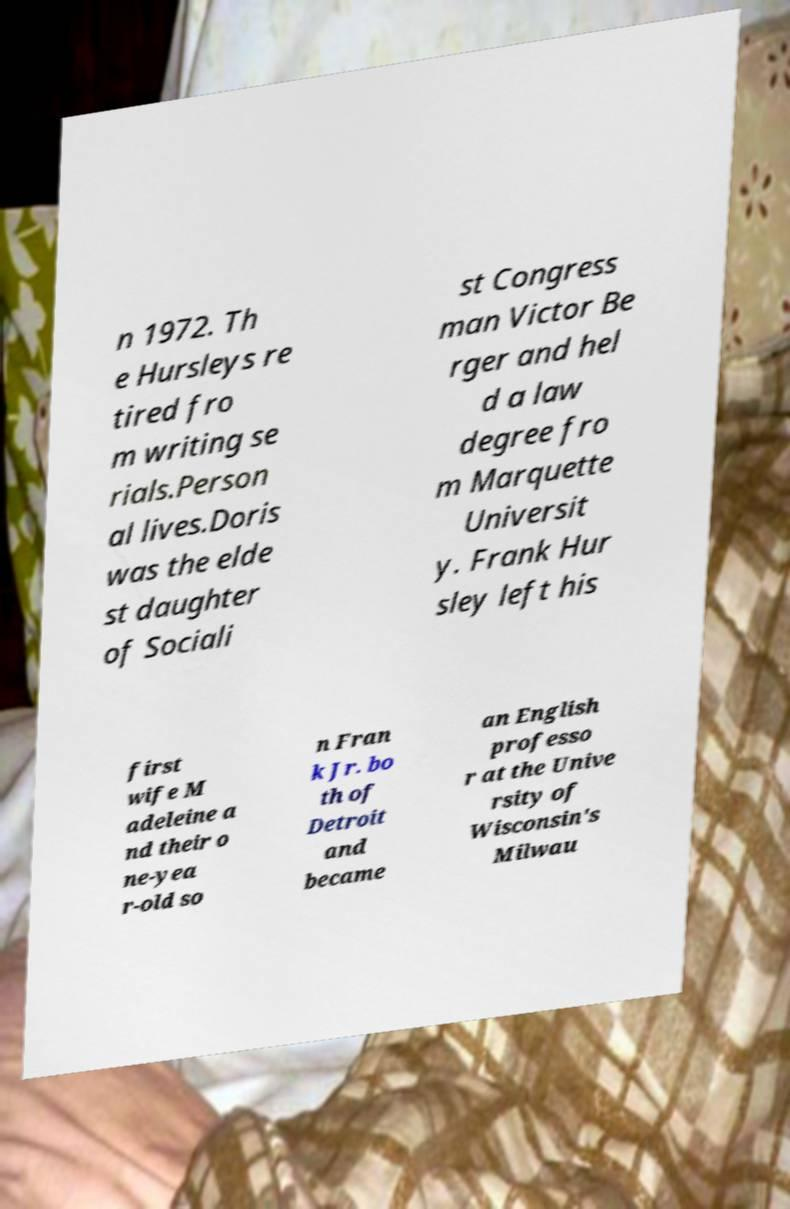Please identify and transcribe the text found in this image. n 1972. Th e Hursleys re tired fro m writing se rials.Person al lives.Doris was the elde st daughter of Sociali st Congress man Victor Be rger and hel d a law degree fro m Marquette Universit y. Frank Hur sley left his first wife M adeleine a nd their o ne-yea r-old so n Fran k Jr. bo th of Detroit and became an English professo r at the Unive rsity of Wisconsin's Milwau 